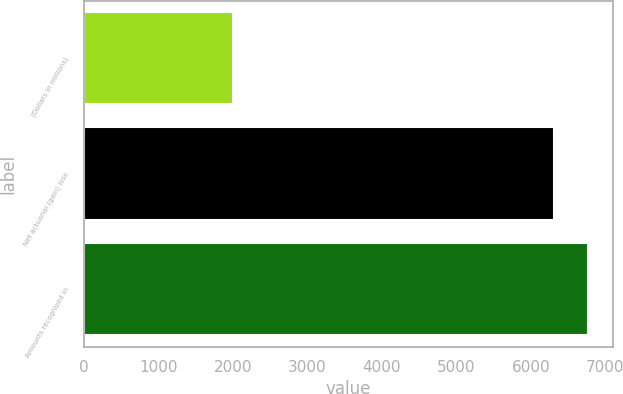Convert chart to OTSL. <chart><loc_0><loc_0><loc_500><loc_500><bar_chart><fcel>(Dollars in millions)<fcel>Net actuarial (gain) loss<fcel>Amounts recognized in<nl><fcel>2009<fcel>6310<fcel>6760<nl></chart> 